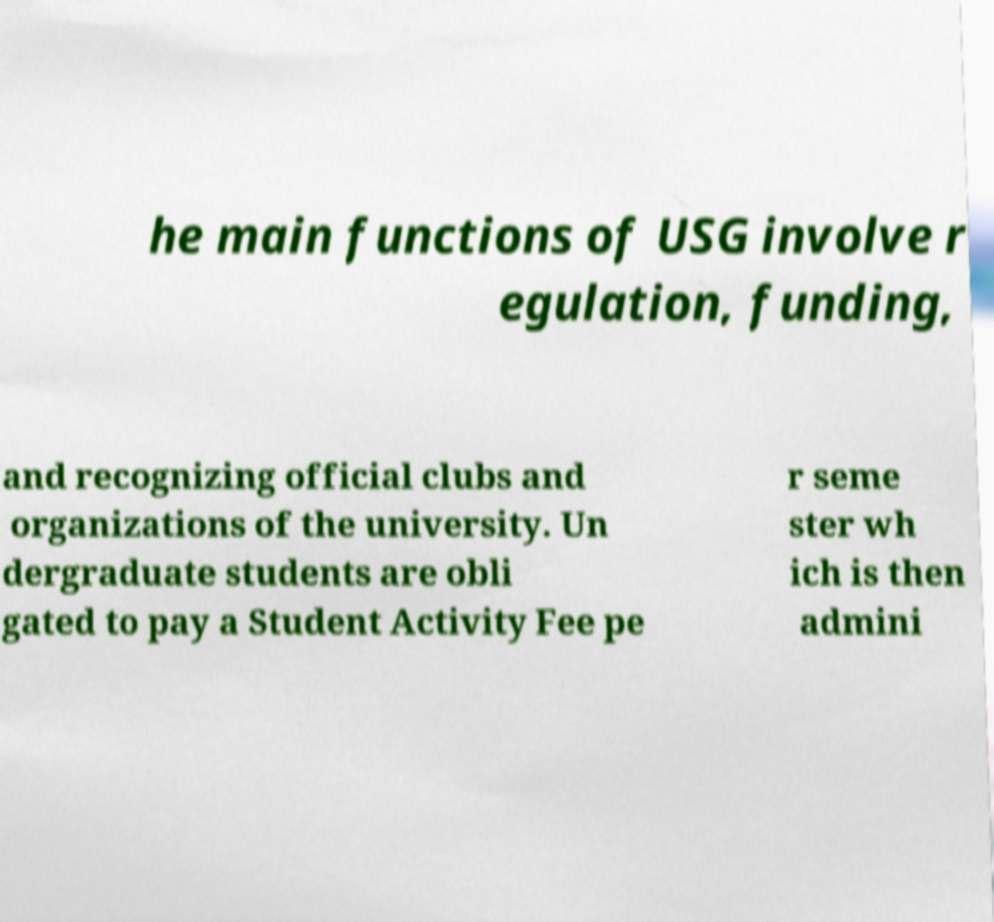For documentation purposes, I need the text within this image transcribed. Could you provide that? he main functions of USG involve r egulation, funding, and recognizing official clubs and organizations of the university. Un dergraduate students are obli gated to pay a Student Activity Fee pe r seme ster wh ich is then admini 